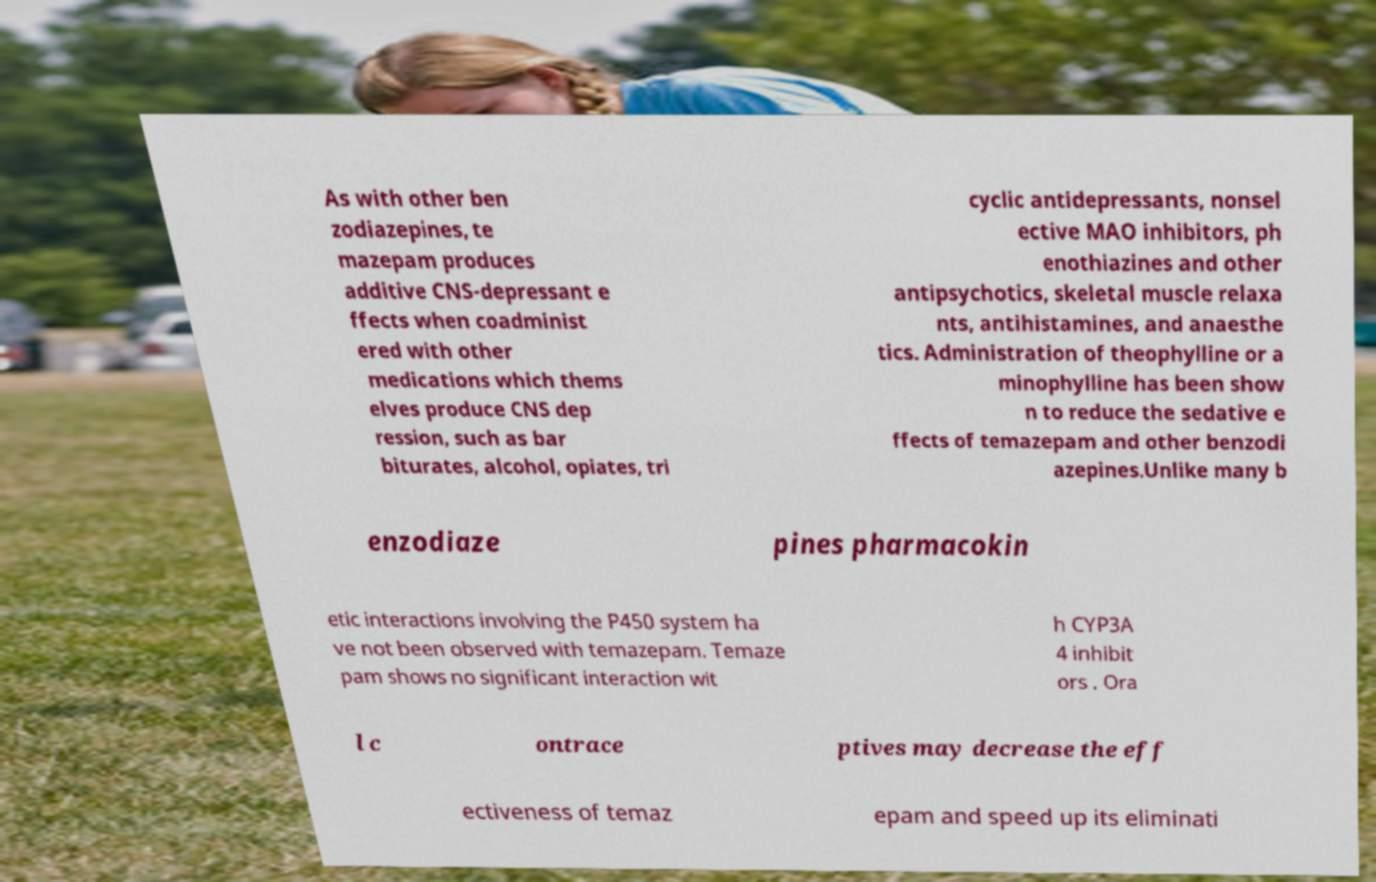Please read and relay the text visible in this image. What does it say? As with other ben zodiazepines, te mazepam produces additive CNS-depressant e ffects when coadminist ered with other medications which thems elves produce CNS dep ression, such as bar biturates, alcohol, opiates, tri cyclic antidepressants, nonsel ective MAO inhibitors, ph enothiazines and other antipsychotics, skeletal muscle relaxa nts, antihistamines, and anaesthe tics. Administration of theophylline or a minophylline has been show n to reduce the sedative e ffects of temazepam and other benzodi azepines.Unlike many b enzodiaze pines pharmacokin etic interactions involving the P450 system ha ve not been observed with temazepam. Temaze pam shows no significant interaction wit h CYP3A 4 inhibit ors . Ora l c ontrace ptives may decrease the eff ectiveness of temaz epam and speed up its eliminati 